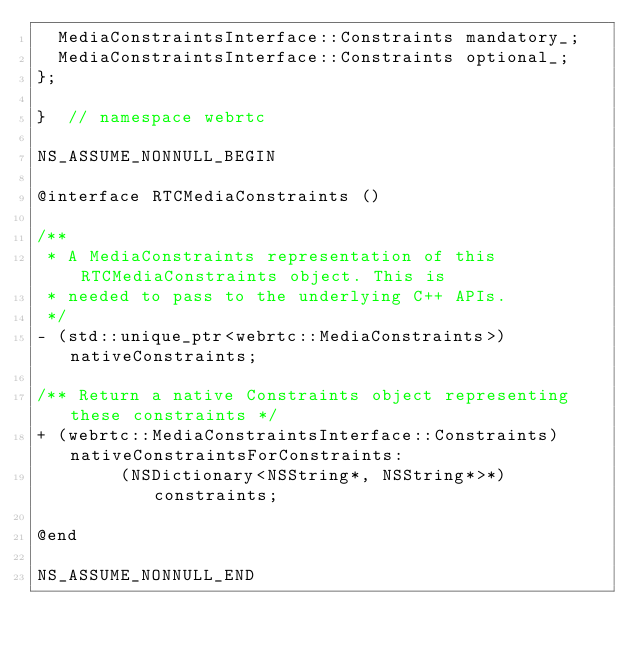<code> <loc_0><loc_0><loc_500><loc_500><_C_>  MediaConstraintsInterface::Constraints mandatory_;
  MediaConstraintsInterface::Constraints optional_;
};

}  // namespace webrtc

NS_ASSUME_NONNULL_BEGIN

@interface RTCMediaConstraints ()

/**
 * A MediaConstraints representation of this RTCMediaConstraints object. This is
 * needed to pass to the underlying C++ APIs.
 */
- (std::unique_ptr<webrtc::MediaConstraints>)nativeConstraints;

/** Return a native Constraints object representing these constraints */
+ (webrtc::MediaConstraintsInterface::Constraints)nativeConstraintsForConstraints:
        (NSDictionary<NSString*, NSString*>*)constraints;

@end

NS_ASSUME_NONNULL_END
</code> 